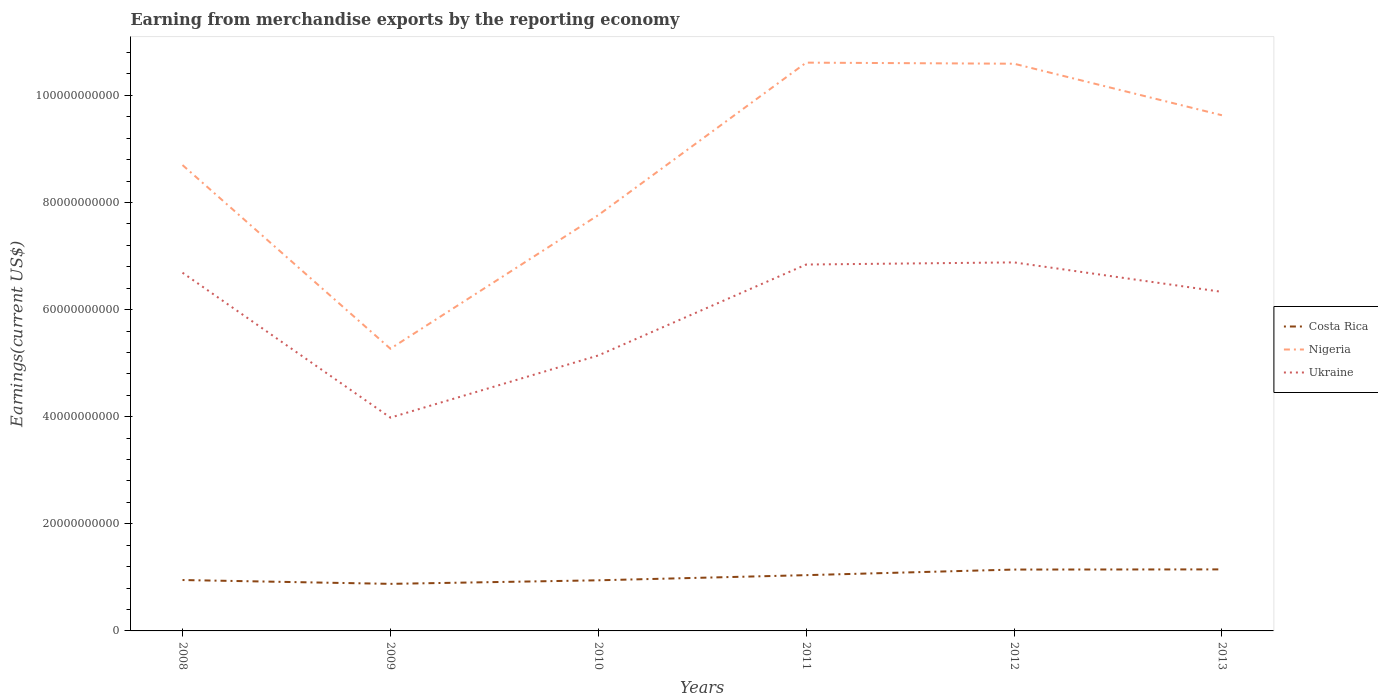How many different coloured lines are there?
Offer a terse response. 3. Is the number of lines equal to the number of legend labels?
Offer a very short reply. Yes. Across all years, what is the maximum amount earned from merchandise exports in Ukraine?
Provide a succinct answer. 3.98e+1. What is the total amount earned from merchandise exports in Costa Rica in the graph?
Provide a short and direct response. 7.16e+08. What is the difference between the highest and the second highest amount earned from merchandise exports in Ukraine?
Provide a succinct answer. 2.90e+1. Is the amount earned from merchandise exports in Costa Rica strictly greater than the amount earned from merchandise exports in Nigeria over the years?
Ensure brevity in your answer.  Yes. Are the values on the major ticks of Y-axis written in scientific E-notation?
Make the answer very short. No. What is the title of the graph?
Make the answer very short. Earning from merchandise exports by the reporting economy. Does "Europe(developing only)" appear as one of the legend labels in the graph?
Your answer should be very brief. No. What is the label or title of the Y-axis?
Offer a terse response. Earnings(current US$). What is the Earnings(current US$) of Costa Rica in 2008?
Give a very brief answer. 9.50e+09. What is the Earnings(current US$) in Nigeria in 2008?
Your answer should be very brief. 8.70e+1. What is the Earnings(current US$) of Ukraine in 2008?
Your answer should be compact. 6.69e+1. What is the Earnings(current US$) of Costa Rica in 2009?
Offer a very short reply. 8.79e+09. What is the Earnings(current US$) in Nigeria in 2009?
Offer a terse response. 5.27e+1. What is the Earnings(current US$) of Ukraine in 2009?
Make the answer very short. 3.98e+1. What is the Earnings(current US$) in Costa Rica in 2010?
Make the answer very short. 9.45e+09. What is the Earnings(current US$) of Nigeria in 2010?
Make the answer very short. 7.76e+1. What is the Earnings(current US$) of Ukraine in 2010?
Offer a terse response. 5.14e+1. What is the Earnings(current US$) in Costa Rica in 2011?
Provide a short and direct response. 1.04e+1. What is the Earnings(current US$) of Nigeria in 2011?
Make the answer very short. 1.06e+11. What is the Earnings(current US$) of Ukraine in 2011?
Make the answer very short. 6.84e+1. What is the Earnings(current US$) in Costa Rica in 2012?
Offer a very short reply. 1.15e+1. What is the Earnings(current US$) in Nigeria in 2012?
Offer a terse response. 1.06e+11. What is the Earnings(current US$) in Ukraine in 2012?
Your response must be concise. 6.88e+1. What is the Earnings(current US$) in Costa Rica in 2013?
Your response must be concise. 1.15e+1. What is the Earnings(current US$) in Nigeria in 2013?
Provide a short and direct response. 9.63e+1. What is the Earnings(current US$) in Ukraine in 2013?
Ensure brevity in your answer.  6.33e+1. Across all years, what is the maximum Earnings(current US$) in Costa Rica?
Offer a terse response. 1.15e+1. Across all years, what is the maximum Earnings(current US$) of Nigeria?
Your response must be concise. 1.06e+11. Across all years, what is the maximum Earnings(current US$) in Ukraine?
Your answer should be compact. 6.88e+1. Across all years, what is the minimum Earnings(current US$) of Costa Rica?
Ensure brevity in your answer.  8.79e+09. Across all years, what is the minimum Earnings(current US$) in Nigeria?
Offer a terse response. 5.27e+1. Across all years, what is the minimum Earnings(current US$) of Ukraine?
Offer a very short reply. 3.98e+1. What is the total Earnings(current US$) of Costa Rica in the graph?
Offer a terse response. 6.11e+1. What is the total Earnings(current US$) of Nigeria in the graph?
Make the answer very short. 5.26e+11. What is the total Earnings(current US$) in Ukraine in the graph?
Provide a succinct answer. 3.59e+11. What is the difference between the Earnings(current US$) of Costa Rica in 2008 and that in 2009?
Keep it short and to the point. 7.16e+08. What is the difference between the Earnings(current US$) in Nigeria in 2008 and that in 2009?
Your answer should be very brief. 3.43e+1. What is the difference between the Earnings(current US$) in Ukraine in 2008 and that in 2009?
Make the answer very short. 2.71e+1. What is the difference between the Earnings(current US$) of Costa Rica in 2008 and that in 2010?
Keep it short and to the point. 5.18e+07. What is the difference between the Earnings(current US$) in Nigeria in 2008 and that in 2010?
Offer a terse response. 9.35e+09. What is the difference between the Earnings(current US$) of Ukraine in 2008 and that in 2010?
Make the answer very short. 1.55e+1. What is the difference between the Earnings(current US$) of Costa Rica in 2008 and that in 2011?
Your answer should be very brief. -9.09e+08. What is the difference between the Earnings(current US$) of Nigeria in 2008 and that in 2011?
Provide a short and direct response. -1.91e+1. What is the difference between the Earnings(current US$) in Ukraine in 2008 and that in 2011?
Ensure brevity in your answer.  -1.53e+09. What is the difference between the Earnings(current US$) in Costa Rica in 2008 and that in 2012?
Your answer should be compact. -1.95e+09. What is the difference between the Earnings(current US$) in Nigeria in 2008 and that in 2012?
Keep it short and to the point. -1.89e+1. What is the difference between the Earnings(current US$) in Ukraine in 2008 and that in 2012?
Give a very brief answer. -1.93e+09. What is the difference between the Earnings(current US$) in Costa Rica in 2008 and that in 2013?
Offer a very short reply. -1.99e+09. What is the difference between the Earnings(current US$) in Nigeria in 2008 and that in 2013?
Ensure brevity in your answer.  -9.30e+09. What is the difference between the Earnings(current US$) of Ukraine in 2008 and that in 2013?
Provide a short and direct response. 3.57e+09. What is the difference between the Earnings(current US$) in Costa Rica in 2009 and that in 2010?
Provide a short and direct response. -6.64e+08. What is the difference between the Earnings(current US$) of Nigeria in 2009 and that in 2010?
Provide a succinct answer. -2.49e+1. What is the difference between the Earnings(current US$) of Ukraine in 2009 and that in 2010?
Provide a short and direct response. -1.16e+1. What is the difference between the Earnings(current US$) in Costa Rica in 2009 and that in 2011?
Give a very brief answer. -1.63e+09. What is the difference between the Earnings(current US$) in Nigeria in 2009 and that in 2011?
Make the answer very short. -5.34e+1. What is the difference between the Earnings(current US$) in Ukraine in 2009 and that in 2011?
Provide a succinct answer. -2.86e+1. What is the difference between the Earnings(current US$) in Costa Rica in 2009 and that in 2012?
Offer a terse response. -2.67e+09. What is the difference between the Earnings(current US$) in Nigeria in 2009 and that in 2012?
Your answer should be very brief. -5.32e+1. What is the difference between the Earnings(current US$) in Ukraine in 2009 and that in 2012?
Give a very brief answer. -2.90e+1. What is the difference between the Earnings(current US$) of Costa Rica in 2009 and that in 2013?
Offer a very short reply. -2.70e+09. What is the difference between the Earnings(current US$) in Nigeria in 2009 and that in 2013?
Ensure brevity in your answer.  -4.36e+1. What is the difference between the Earnings(current US$) in Ukraine in 2009 and that in 2013?
Your answer should be compact. -2.35e+1. What is the difference between the Earnings(current US$) in Costa Rica in 2010 and that in 2011?
Your answer should be very brief. -9.61e+08. What is the difference between the Earnings(current US$) of Nigeria in 2010 and that in 2011?
Provide a succinct answer. -2.85e+1. What is the difference between the Earnings(current US$) of Ukraine in 2010 and that in 2011?
Give a very brief answer. -1.70e+1. What is the difference between the Earnings(current US$) of Costa Rica in 2010 and that in 2012?
Make the answer very short. -2.01e+09. What is the difference between the Earnings(current US$) of Nigeria in 2010 and that in 2012?
Offer a terse response. -2.83e+1. What is the difference between the Earnings(current US$) in Ukraine in 2010 and that in 2012?
Provide a succinct answer. -1.74e+1. What is the difference between the Earnings(current US$) of Costa Rica in 2010 and that in 2013?
Provide a short and direct response. -2.04e+09. What is the difference between the Earnings(current US$) in Nigeria in 2010 and that in 2013?
Offer a terse response. -1.86e+1. What is the difference between the Earnings(current US$) of Ukraine in 2010 and that in 2013?
Give a very brief answer. -1.19e+1. What is the difference between the Earnings(current US$) in Costa Rica in 2011 and that in 2012?
Offer a terse response. -1.04e+09. What is the difference between the Earnings(current US$) in Nigeria in 2011 and that in 2012?
Offer a terse response. 2.02e+08. What is the difference between the Earnings(current US$) of Ukraine in 2011 and that in 2012?
Offer a very short reply. -3.98e+08. What is the difference between the Earnings(current US$) of Costa Rica in 2011 and that in 2013?
Offer a very short reply. -1.08e+09. What is the difference between the Earnings(current US$) in Nigeria in 2011 and that in 2013?
Keep it short and to the point. 9.82e+09. What is the difference between the Earnings(current US$) in Ukraine in 2011 and that in 2013?
Give a very brief answer. 5.10e+09. What is the difference between the Earnings(current US$) of Costa Rica in 2012 and that in 2013?
Make the answer very short. -3.11e+07. What is the difference between the Earnings(current US$) in Nigeria in 2012 and that in 2013?
Give a very brief answer. 9.62e+09. What is the difference between the Earnings(current US$) of Ukraine in 2012 and that in 2013?
Offer a very short reply. 5.50e+09. What is the difference between the Earnings(current US$) of Costa Rica in 2008 and the Earnings(current US$) of Nigeria in 2009?
Make the answer very short. -4.32e+1. What is the difference between the Earnings(current US$) in Costa Rica in 2008 and the Earnings(current US$) in Ukraine in 2009?
Offer a terse response. -3.03e+1. What is the difference between the Earnings(current US$) of Nigeria in 2008 and the Earnings(current US$) of Ukraine in 2009?
Your answer should be very brief. 4.72e+1. What is the difference between the Earnings(current US$) in Costa Rica in 2008 and the Earnings(current US$) in Nigeria in 2010?
Offer a very short reply. -6.81e+1. What is the difference between the Earnings(current US$) in Costa Rica in 2008 and the Earnings(current US$) in Ukraine in 2010?
Offer a terse response. -4.19e+1. What is the difference between the Earnings(current US$) of Nigeria in 2008 and the Earnings(current US$) of Ukraine in 2010?
Offer a terse response. 3.56e+1. What is the difference between the Earnings(current US$) in Costa Rica in 2008 and the Earnings(current US$) in Nigeria in 2011?
Offer a very short reply. -9.66e+1. What is the difference between the Earnings(current US$) in Costa Rica in 2008 and the Earnings(current US$) in Ukraine in 2011?
Make the answer very short. -5.89e+1. What is the difference between the Earnings(current US$) of Nigeria in 2008 and the Earnings(current US$) of Ukraine in 2011?
Keep it short and to the point. 1.86e+1. What is the difference between the Earnings(current US$) in Costa Rica in 2008 and the Earnings(current US$) in Nigeria in 2012?
Offer a terse response. -9.64e+1. What is the difference between the Earnings(current US$) of Costa Rica in 2008 and the Earnings(current US$) of Ukraine in 2012?
Offer a very short reply. -5.93e+1. What is the difference between the Earnings(current US$) in Nigeria in 2008 and the Earnings(current US$) in Ukraine in 2012?
Keep it short and to the point. 1.82e+1. What is the difference between the Earnings(current US$) of Costa Rica in 2008 and the Earnings(current US$) of Nigeria in 2013?
Keep it short and to the point. -8.68e+1. What is the difference between the Earnings(current US$) in Costa Rica in 2008 and the Earnings(current US$) in Ukraine in 2013?
Ensure brevity in your answer.  -5.38e+1. What is the difference between the Earnings(current US$) in Nigeria in 2008 and the Earnings(current US$) in Ukraine in 2013?
Your answer should be very brief. 2.37e+1. What is the difference between the Earnings(current US$) in Costa Rica in 2009 and the Earnings(current US$) in Nigeria in 2010?
Keep it short and to the point. -6.88e+1. What is the difference between the Earnings(current US$) of Costa Rica in 2009 and the Earnings(current US$) of Ukraine in 2010?
Your answer should be compact. -4.26e+1. What is the difference between the Earnings(current US$) of Nigeria in 2009 and the Earnings(current US$) of Ukraine in 2010?
Keep it short and to the point. 1.26e+09. What is the difference between the Earnings(current US$) in Costa Rica in 2009 and the Earnings(current US$) in Nigeria in 2011?
Keep it short and to the point. -9.73e+1. What is the difference between the Earnings(current US$) in Costa Rica in 2009 and the Earnings(current US$) in Ukraine in 2011?
Offer a very short reply. -5.96e+1. What is the difference between the Earnings(current US$) of Nigeria in 2009 and the Earnings(current US$) of Ukraine in 2011?
Your answer should be very brief. -1.57e+1. What is the difference between the Earnings(current US$) in Costa Rica in 2009 and the Earnings(current US$) in Nigeria in 2012?
Keep it short and to the point. -9.71e+1. What is the difference between the Earnings(current US$) of Costa Rica in 2009 and the Earnings(current US$) of Ukraine in 2012?
Your answer should be very brief. -6.00e+1. What is the difference between the Earnings(current US$) in Nigeria in 2009 and the Earnings(current US$) in Ukraine in 2012?
Ensure brevity in your answer.  -1.61e+1. What is the difference between the Earnings(current US$) in Costa Rica in 2009 and the Earnings(current US$) in Nigeria in 2013?
Your response must be concise. -8.75e+1. What is the difference between the Earnings(current US$) of Costa Rica in 2009 and the Earnings(current US$) of Ukraine in 2013?
Keep it short and to the point. -5.45e+1. What is the difference between the Earnings(current US$) of Nigeria in 2009 and the Earnings(current US$) of Ukraine in 2013?
Your answer should be very brief. -1.06e+1. What is the difference between the Earnings(current US$) in Costa Rica in 2010 and the Earnings(current US$) in Nigeria in 2011?
Your response must be concise. -9.67e+1. What is the difference between the Earnings(current US$) in Costa Rica in 2010 and the Earnings(current US$) in Ukraine in 2011?
Offer a terse response. -5.90e+1. What is the difference between the Earnings(current US$) in Nigeria in 2010 and the Earnings(current US$) in Ukraine in 2011?
Make the answer very short. 9.23e+09. What is the difference between the Earnings(current US$) of Costa Rica in 2010 and the Earnings(current US$) of Nigeria in 2012?
Provide a short and direct response. -9.65e+1. What is the difference between the Earnings(current US$) of Costa Rica in 2010 and the Earnings(current US$) of Ukraine in 2012?
Keep it short and to the point. -5.94e+1. What is the difference between the Earnings(current US$) of Nigeria in 2010 and the Earnings(current US$) of Ukraine in 2012?
Provide a short and direct response. 8.83e+09. What is the difference between the Earnings(current US$) in Costa Rica in 2010 and the Earnings(current US$) in Nigeria in 2013?
Provide a short and direct response. -8.68e+1. What is the difference between the Earnings(current US$) of Costa Rica in 2010 and the Earnings(current US$) of Ukraine in 2013?
Provide a short and direct response. -5.39e+1. What is the difference between the Earnings(current US$) in Nigeria in 2010 and the Earnings(current US$) in Ukraine in 2013?
Make the answer very short. 1.43e+1. What is the difference between the Earnings(current US$) of Costa Rica in 2011 and the Earnings(current US$) of Nigeria in 2012?
Provide a short and direct response. -9.55e+1. What is the difference between the Earnings(current US$) in Costa Rica in 2011 and the Earnings(current US$) in Ukraine in 2012?
Give a very brief answer. -5.84e+1. What is the difference between the Earnings(current US$) in Nigeria in 2011 and the Earnings(current US$) in Ukraine in 2012?
Ensure brevity in your answer.  3.73e+1. What is the difference between the Earnings(current US$) in Costa Rica in 2011 and the Earnings(current US$) in Nigeria in 2013?
Your answer should be very brief. -8.59e+1. What is the difference between the Earnings(current US$) in Costa Rica in 2011 and the Earnings(current US$) in Ukraine in 2013?
Your answer should be compact. -5.29e+1. What is the difference between the Earnings(current US$) in Nigeria in 2011 and the Earnings(current US$) in Ukraine in 2013?
Your response must be concise. 4.28e+1. What is the difference between the Earnings(current US$) in Costa Rica in 2012 and the Earnings(current US$) in Nigeria in 2013?
Ensure brevity in your answer.  -8.48e+1. What is the difference between the Earnings(current US$) in Costa Rica in 2012 and the Earnings(current US$) in Ukraine in 2013?
Ensure brevity in your answer.  -5.19e+1. What is the difference between the Earnings(current US$) of Nigeria in 2012 and the Earnings(current US$) of Ukraine in 2013?
Give a very brief answer. 4.26e+1. What is the average Earnings(current US$) in Costa Rica per year?
Give a very brief answer. 1.02e+1. What is the average Earnings(current US$) of Nigeria per year?
Give a very brief answer. 8.76e+1. What is the average Earnings(current US$) of Ukraine per year?
Your response must be concise. 5.98e+1. In the year 2008, what is the difference between the Earnings(current US$) in Costa Rica and Earnings(current US$) in Nigeria?
Your answer should be compact. -7.75e+1. In the year 2008, what is the difference between the Earnings(current US$) in Costa Rica and Earnings(current US$) in Ukraine?
Provide a succinct answer. -5.74e+1. In the year 2008, what is the difference between the Earnings(current US$) of Nigeria and Earnings(current US$) of Ukraine?
Give a very brief answer. 2.01e+1. In the year 2009, what is the difference between the Earnings(current US$) in Costa Rica and Earnings(current US$) in Nigeria?
Provide a short and direct response. -4.39e+1. In the year 2009, what is the difference between the Earnings(current US$) of Costa Rica and Earnings(current US$) of Ukraine?
Offer a terse response. -3.10e+1. In the year 2009, what is the difference between the Earnings(current US$) in Nigeria and Earnings(current US$) in Ukraine?
Provide a succinct answer. 1.29e+1. In the year 2010, what is the difference between the Earnings(current US$) of Costa Rica and Earnings(current US$) of Nigeria?
Give a very brief answer. -6.82e+1. In the year 2010, what is the difference between the Earnings(current US$) in Costa Rica and Earnings(current US$) in Ukraine?
Provide a short and direct response. -4.20e+1. In the year 2010, what is the difference between the Earnings(current US$) in Nigeria and Earnings(current US$) in Ukraine?
Make the answer very short. 2.62e+1. In the year 2011, what is the difference between the Earnings(current US$) of Costa Rica and Earnings(current US$) of Nigeria?
Offer a very short reply. -9.57e+1. In the year 2011, what is the difference between the Earnings(current US$) of Costa Rica and Earnings(current US$) of Ukraine?
Your response must be concise. -5.80e+1. In the year 2011, what is the difference between the Earnings(current US$) in Nigeria and Earnings(current US$) in Ukraine?
Offer a terse response. 3.77e+1. In the year 2012, what is the difference between the Earnings(current US$) in Costa Rica and Earnings(current US$) in Nigeria?
Offer a very short reply. -9.44e+1. In the year 2012, what is the difference between the Earnings(current US$) of Costa Rica and Earnings(current US$) of Ukraine?
Make the answer very short. -5.74e+1. In the year 2012, what is the difference between the Earnings(current US$) in Nigeria and Earnings(current US$) in Ukraine?
Make the answer very short. 3.71e+1. In the year 2013, what is the difference between the Earnings(current US$) in Costa Rica and Earnings(current US$) in Nigeria?
Make the answer very short. -8.48e+1. In the year 2013, what is the difference between the Earnings(current US$) of Costa Rica and Earnings(current US$) of Ukraine?
Keep it short and to the point. -5.18e+1. In the year 2013, what is the difference between the Earnings(current US$) of Nigeria and Earnings(current US$) of Ukraine?
Ensure brevity in your answer.  3.30e+1. What is the ratio of the Earnings(current US$) of Costa Rica in 2008 to that in 2009?
Offer a very short reply. 1.08. What is the ratio of the Earnings(current US$) in Nigeria in 2008 to that in 2009?
Offer a very short reply. 1.65. What is the ratio of the Earnings(current US$) in Ukraine in 2008 to that in 2009?
Provide a short and direct response. 1.68. What is the ratio of the Earnings(current US$) of Nigeria in 2008 to that in 2010?
Your answer should be very brief. 1.12. What is the ratio of the Earnings(current US$) of Ukraine in 2008 to that in 2010?
Your answer should be very brief. 1.3. What is the ratio of the Earnings(current US$) in Costa Rica in 2008 to that in 2011?
Ensure brevity in your answer.  0.91. What is the ratio of the Earnings(current US$) of Nigeria in 2008 to that in 2011?
Keep it short and to the point. 0.82. What is the ratio of the Earnings(current US$) in Ukraine in 2008 to that in 2011?
Make the answer very short. 0.98. What is the ratio of the Earnings(current US$) of Costa Rica in 2008 to that in 2012?
Make the answer very short. 0.83. What is the ratio of the Earnings(current US$) in Nigeria in 2008 to that in 2012?
Give a very brief answer. 0.82. What is the ratio of the Earnings(current US$) of Costa Rica in 2008 to that in 2013?
Give a very brief answer. 0.83. What is the ratio of the Earnings(current US$) in Nigeria in 2008 to that in 2013?
Offer a very short reply. 0.9. What is the ratio of the Earnings(current US$) of Ukraine in 2008 to that in 2013?
Your response must be concise. 1.06. What is the ratio of the Earnings(current US$) in Costa Rica in 2009 to that in 2010?
Provide a succinct answer. 0.93. What is the ratio of the Earnings(current US$) of Nigeria in 2009 to that in 2010?
Make the answer very short. 0.68. What is the ratio of the Earnings(current US$) in Ukraine in 2009 to that in 2010?
Your answer should be compact. 0.77. What is the ratio of the Earnings(current US$) of Costa Rica in 2009 to that in 2011?
Provide a succinct answer. 0.84. What is the ratio of the Earnings(current US$) in Nigeria in 2009 to that in 2011?
Keep it short and to the point. 0.5. What is the ratio of the Earnings(current US$) of Ukraine in 2009 to that in 2011?
Offer a very short reply. 0.58. What is the ratio of the Earnings(current US$) in Costa Rica in 2009 to that in 2012?
Keep it short and to the point. 0.77. What is the ratio of the Earnings(current US$) of Nigeria in 2009 to that in 2012?
Provide a short and direct response. 0.5. What is the ratio of the Earnings(current US$) of Ukraine in 2009 to that in 2012?
Offer a terse response. 0.58. What is the ratio of the Earnings(current US$) of Costa Rica in 2009 to that in 2013?
Your answer should be very brief. 0.76. What is the ratio of the Earnings(current US$) in Nigeria in 2009 to that in 2013?
Keep it short and to the point. 0.55. What is the ratio of the Earnings(current US$) in Ukraine in 2009 to that in 2013?
Offer a terse response. 0.63. What is the ratio of the Earnings(current US$) of Costa Rica in 2010 to that in 2011?
Ensure brevity in your answer.  0.91. What is the ratio of the Earnings(current US$) in Nigeria in 2010 to that in 2011?
Make the answer very short. 0.73. What is the ratio of the Earnings(current US$) of Ukraine in 2010 to that in 2011?
Keep it short and to the point. 0.75. What is the ratio of the Earnings(current US$) of Costa Rica in 2010 to that in 2012?
Make the answer very short. 0.82. What is the ratio of the Earnings(current US$) in Nigeria in 2010 to that in 2012?
Give a very brief answer. 0.73. What is the ratio of the Earnings(current US$) of Ukraine in 2010 to that in 2012?
Provide a succinct answer. 0.75. What is the ratio of the Earnings(current US$) in Costa Rica in 2010 to that in 2013?
Your response must be concise. 0.82. What is the ratio of the Earnings(current US$) of Nigeria in 2010 to that in 2013?
Give a very brief answer. 0.81. What is the ratio of the Earnings(current US$) of Ukraine in 2010 to that in 2013?
Provide a succinct answer. 0.81. What is the ratio of the Earnings(current US$) of Costa Rica in 2011 to that in 2012?
Give a very brief answer. 0.91. What is the ratio of the Earnings(current US$) in Nigeria in 2011 to that in 2012?
Your response must be concise. 1. What is the ratio of the Earnings(current US$) of Costa Rica in 2011 to that in 2013?
Offer a terse response. 0.91. What is the ratio of the Earnings(current US$) of Nigeria in 2011 to that in 2013?
Your response must be concise. 1.1. What is the ratio of the Earnings(current US$) in Ukraine in 2011 to that in 2013?
Your answer should be compact. 1.08. What is the ratio of the Earnings(current US$) of Nigeria in 2012 to that in 2013?
Provide a succinct answer. 1.1. What is the ratio of the Earnings(current US$) in Ukraine in 2012 to that in 2013?
Give a very brief answer. 1.09. What is the difference between the highest and the second highest Earnings(current US$) of Costa Rica?
Provide a succinct answer. 3.11e+07. What is the difference between the highest and the second highest Earnings(current US$) of Nigeria?
Your response must be concise. 2.02e+08. What is the difference between the highest and the second highest Earnings(current US$) in Ukraine?
Your answer should be very brief. 3.98e+08. What is the difference between the highest and the lowest Earnings(current US$) in Costa Rica?
Offer a very short reply. 2.70e+09. What is the difference between the highest and the lowest Earnings(current US$) in Nigeria?
Your answer should be compact. 5.34e+1. What is the difference between the highest and the lowest Earnings(current US$) of Ukraine?
Your answer should be compact. 2.90e+1. 